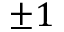Convert formula to latex. <formula><loc_0><loc_0><loc_500><loc_500>\pm 1</formula> 